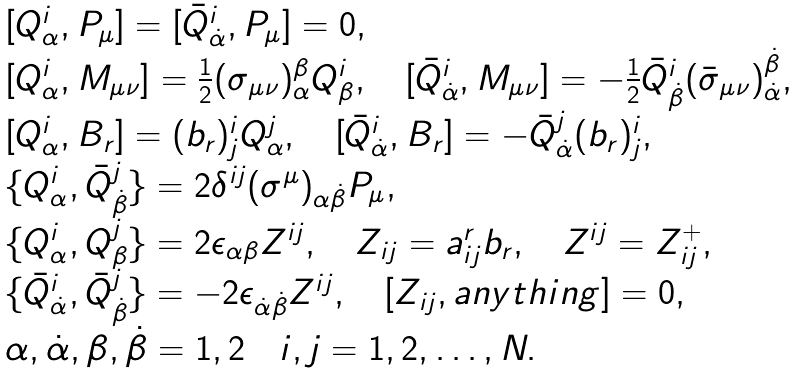<formula> <loc_0><loc_0><loc_500><loc_500>\begin{array} { l } { [ } Q _ { \alpha } ^ { i } , P _ { \mu } { ] } = { [ } \bar { Q } _ { \dot { \alpha } } ^ { i } , P _ { \mu } { ] } = 0 , \\ { [ } Q _ { \alpha } ^ { i } , M _ { \mu \nu } { ] } = \frac { 1 } { 2 } ( \sigma _ { \mu \nu } ) _ { \alpha } ^ { \beta } Q _ { \beta } ^ { i } , \quad { [ } \bar { Q } _ { \dot { \alpha } } ^ { i } , M _ { \mu \nu } { ] } = - \frac { 1 } { 2 } \bar { Q } _ { \dot { \beta } } ^ { i } ( \bar { \sigma } _ { \mu \nu } ) _ { \dot { \alpha } } ^ { \dot { \beta } } , \\ { [ } Q _ { \alpha } ^ { i } , B _ { r } { ] } = ( b _ { r } ) _ { j } ^ { i } Q _ { \alpha } ^ { j } , \quad { [ } \bar { Q } _ { \dot { \alpha } } ^ { i } , B _ { r } { ] } = - \bar { Q } _ { \dot { \alpha } } ^ { j } ( b _ { r } ) _ { j } ^ { i } , \\ \{ Q _ { \alpha } ^ { i } , \bar { Q } _ { \dot { \beta } } ^ { j } \} = 2 \delta ^ { i j } ( \sigma ^ { \mu } ) _ { \alpha \dot { \beta } } P _ { \mu } , \\ \{ Q _ { \alpha } ^ { i } , Q _ { \beta } ^ { j } \} = 2 \epsilon _ { \alpha \beta } Z ^ { i j } , \quad Z _ { i j } = a _ { i j } ^ { r } b _ { r } , \quad Z ^ { i j } = Z _ { i j } ^ { + } , \\ \{ \bar { Q } _ { \dot { \alpha } } ^ { i } , \bar { Q } _ { \dot { \beta } } ^ { j } \} = - 2 \epsilon _ { \dot { \alpha } \dot { \beta } } Z ^ { i j } , \quad { [ } Z _ { i j } , a n y t h i n g { ] } = 0 , \\ \alpha , \dot { \alpha } , \beta , \dot { \beta } = 1 , 2 \quad i , j = 1 , 2 , \dots , N . \end{array}</formula> 